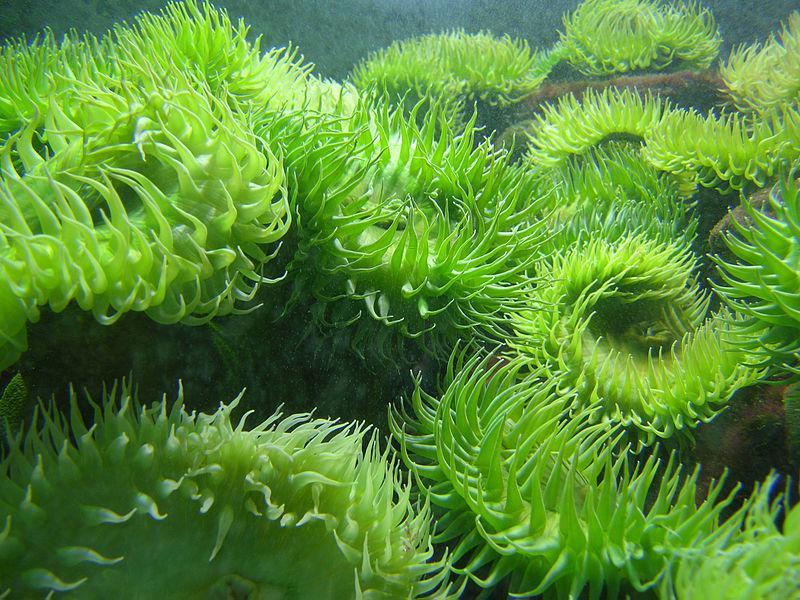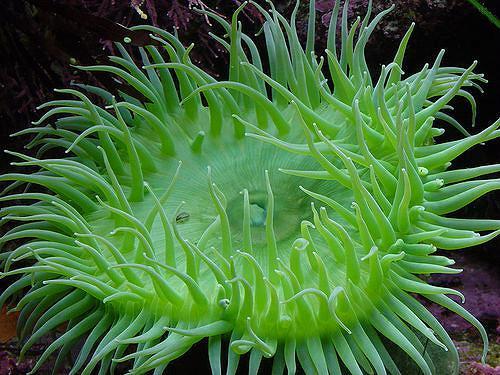The first image is the image on the left, the second image is the image on the right. Considering the images on both sides, is "Each image features lime-green anemone with tapered tendrils, and at least one image contains a single lime-green anemone." valid? Answer yes or no. Yes. The first image is the image on the left, the second image is the image on the right. Evaluate the accuracy of this statement regarding the images: "There are more sea organisms in the image on the left.". Is it true? Answer yes or no. Yes. 